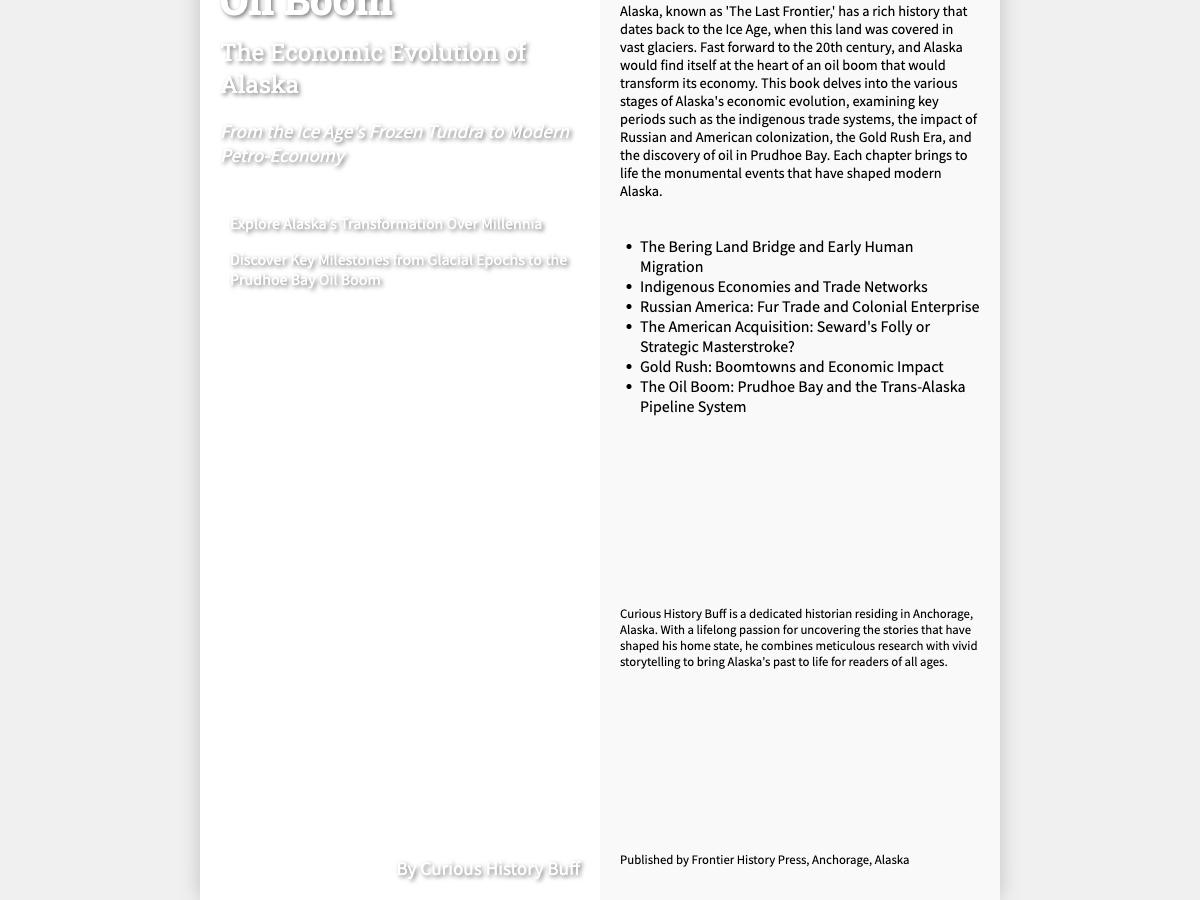what is the title of the book? The title is prominently displayed on the front cover in a large font.
Answer: From Ice Age to Oil Boom who is the author of the book? The author's name is mentioned on the front cover and in the author bio section.
Answer: Curious History Buff what significant economic event is highlighted in the book? The book discusses the key economic development that transformed Alaska in the 20th century.
Answer: Oil Boom what year is associated with the Prudhoe Bay event? While an exact number is not given, it is a significant focus period of the book.
Answer: 20th century what type of trade systems are discussed in the book? The book mentions specific economic structures from Alaska's past.
Answer: Indigenous trade systems how many key periods of Alaska's economic evolution are listed? The summary section lists the important phases Alaska underwent.
Answer: Six what publishing house released the book? The information about the publisher is found on the back cover.
Answer: Frontier History Press what natural landmark is referenced in the book title? The title of the book references a geological period and geographical feature.
Answer: Ice Age what geographical area does the book focus on? The book's content specifically pertains to a particular region in North America.
Answer: Alaska 